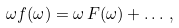<formula> <loc_0><loc_0><loc_500><loc_500>\omega f ( \omega ) = \omega \, F ( \omega ) + \dots \, ,</formula> 